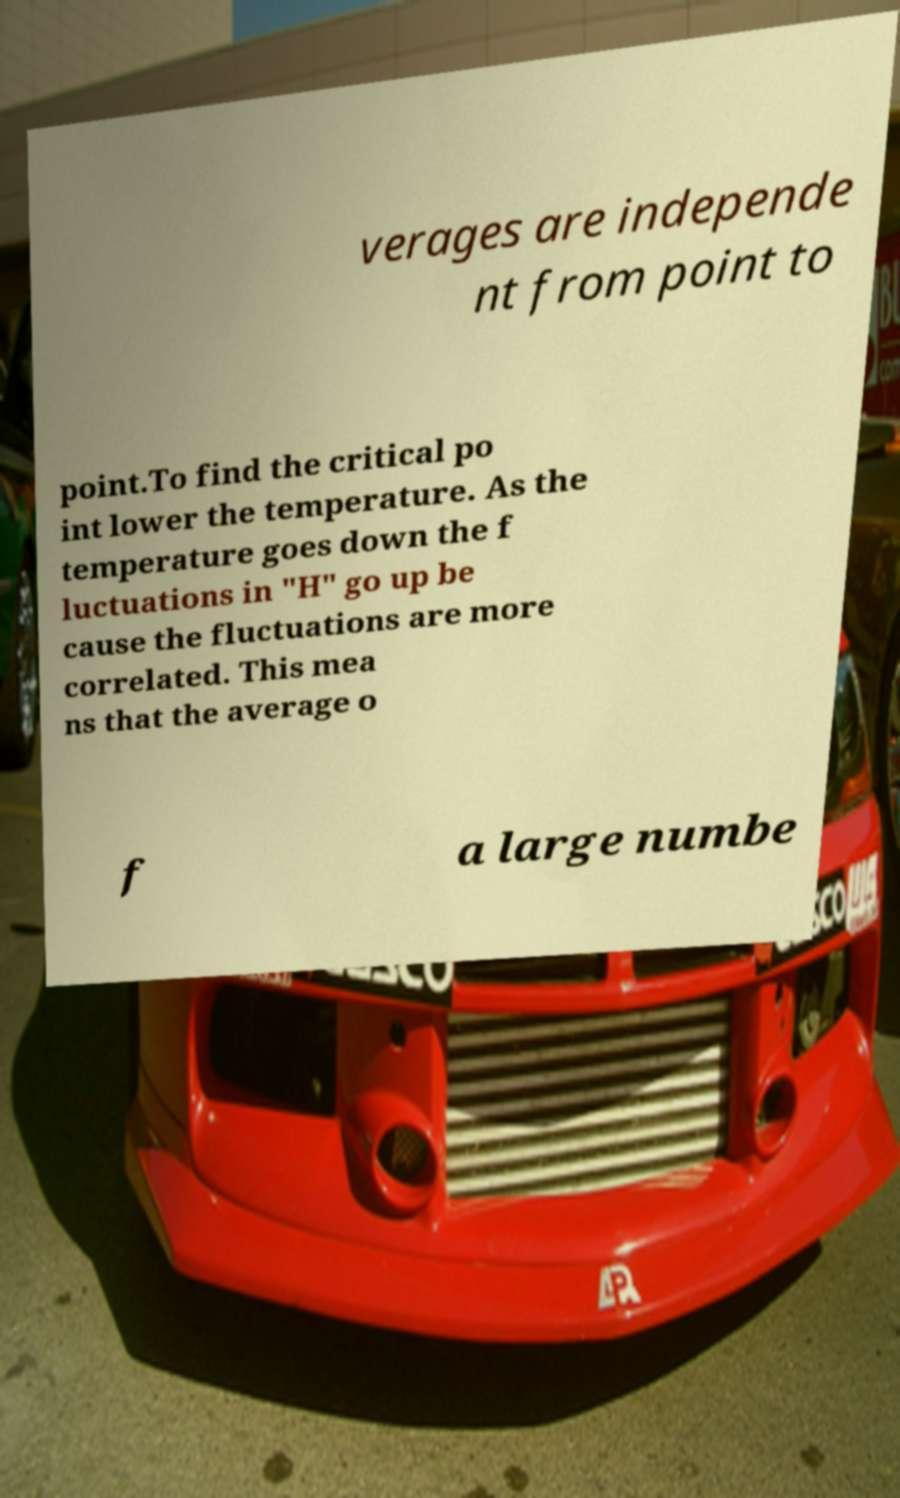Could you extract and type out the text from this image? verages are independe nt from point to point.To find the critical po int lower the temperature. As the temperature goes down the f luctuations in "H" go up be cause the fluctuations are more correlated. This mea ns that the average o f a large numbe 